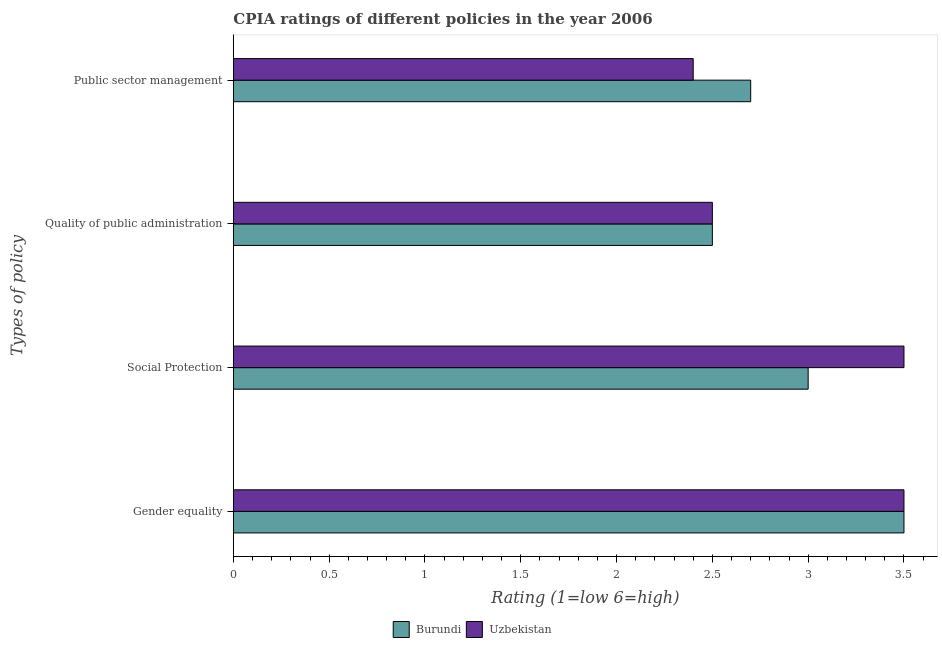How many different coloured bars are there?
Ensure brevity in your answer.  2. Are the number of bars per tick equal to the number of legend labels?
Provide a succinct answer. Yes. How many bars are there on the 2nd tick from the top?
Provide a short and direct response. 2. How many bars are there on the 3rd tick from the bottom?
Give a very brief answer. 2. What is the label of the 2nd group of bars from the top?
Offer a terse response. Quality of public administration. Across all countries, what is the maximum cpia rating of social protection?
Ensure brevity in your answer.  3.5. Across all countries, what is the minimum cpia rating of gender equality?
Provide a short and direct response. 3.5. In which country was the cpia rating of gender equality maximum?
Your answer should be compact. Burundi. In which country was the cpia rating of social protection minimum?
Ensure brevity in your answer.  Burundi. What is the total cpia rating of gender equality in the graph?
Your response must be concise. 7. What is the difference between the cpia rating of quality of public administration in Burundi and the cpia rating of gender equality in Uzbekistan?
Give a very brief answer. -1. What is the average cpia rating of public sector management per country?
Your answer should be very brief. 2.55. What is the difference between the cpia rating of public sector management and cpia rating of social protection in Uzbekistan?
Give a very brief answer. -1.1. Is the cpia rating of social protection in Uzbekistan less than that in Burundi?
Your answer should be very brief. No. What is the difference between the highest and the second highest cpia rating of gender equality?
Your answer should be compact. 0. What is the difference between the highest and the lowest cpia rating of quality of public administration?
Keep it short and to the point. 0. In how many countries, is the cpia rating of gender equality greater than the average cpia rating of gender equality taken over all countries?
Your answer should be compact. 0. Is the sum of the cpia rating of public sector management in Burundi and Uzbekistan greater than the maximum cpia rating of quality of public administration across all countries?
Keep it short and to the point. Yes. What does the 2nd bar from the top in Quality of public administration represents?
Your response must be concise. Burundi. What does the 2nd bar from the bottom in Social Protection represents?
Offer a terse response. Uzbekistan. Is it the case that in every country, the sum of the cpia rating of gender equality and cpia rating of social protection is greater than the cpia rating of quality of public administration?
Ensure brevity in your answer.  Yes. Are all the bars in the graph horizontal?
Keep it short and to the point. Yes. How many countries are there in the graph?
Offer a very short reply. 2. Does the graph contain grids?
Give a very brief answer. No. Where does the legend appear in the graph?
Keep it short and to the point. Bottom center. What is the title of the graph?
Keep it short and to the point. CPIA ratings of different policies in the year 2006. Does "American Samoa" appear as one of the legend labels in the graph?
Your answer should be very brief. No. What is the label or title of the X-axis?
Offer a terse response. Rating (1=low 6=high). What is the label or title of the Y-axis?
Offer a terse response. Types of policy. What is the Rating (1=low 6=high) of Burundi in Gender equality?
Your response must be concise. 3.5. What is the Rating (1=low 6=high) in Uzbekistan in Gender equality?
Provide a succinct answer. 3.5. What is the Rating (1=low 6=high) in Burundi in Social Protection?
Your answer should be compact. 3. What is the Rating (1=low 6=high) of Uzbekistan in Social Protection?
Your response must be concise. 3.5. What is the Rating (1=low 6=high) in Burundi in Quality of public administration?
Offer a very short reply. 2.5. What is the Rating (1=low 6=high) in Burundi in Public sector management?
Offer a terse response. 2.7. Across all Types of policy, what is the minimum Rating (1=low 6=high) of Uzbekistan?
Offer a terse response. 2.4. What is the total Rating (1=low 6=high) of Burundi in the graph?
Provide a short and direct response. 11.7. What is the total Rating (1=low 6=high) of Uzbekistan in the graph?
Your response must be concise. 11.9. What is the difference between the Rating (1=low 6=high) in Burundi in Gender equality and that in Quality of public administration?
Keep it short and to the point. 1. What is the difference between the Rating (1=low 6=high) of Uzbekistan in Gender equality and that in Quality of public administration?
Ensure brevity in your answer.  1. What is the difference between the Rating (1=low 6=high) of Burundi in Gender equality and that in Public sector management?
Your answer should be very brief. 0.8. What is the difference between the Rating (1=low 6=high) in Uzbekistan in Gender equality and that in Public sector management?
Provide a short and direct response. 1.1. What is the difference between the Rating (1=low 6=high) in Burundi in Social Protection and that in Quality of public administration?
Provide a succinct answer. 0.5. What is the difference between the Rating (1=low 6=high) of Burundi in Quality of public administration and that in Public sector management?
Ensure brevity in your answer.  -0.2. What is the difference between the Rating (1=low 6=high) in Uzbekistan in Quality of public administration and that in Public sector management?
Ensure brevity in your answer.  0.1. What is the difference between the Rating (1=low 6=high) in Burundi in Gender equality and the Rating (1=low 6=high) in Uzbekistan in Social Protection?
Your response must be concise. 0. What is the difference between the Rating (1=low 6=high) in Burundi in Gender equality and the Rating (1=low 6=high) in Uzbekistan in Public sector management?
Give a very brief answer. 1.1. What is the average Rating (1=low 6=high) in Burundi per Types of policy?
Provide a succinct answer. 2.92. What is the average Rating (1=low 6=high) of Uzbekistan per Types of policy?
Offer a terse response. 2.98. What is the ratio of the Rating (1=low 6=high) in Burundi in Gender equality to that in Social Protection?
Your response must be concise. 1.17. What is the ratio of the Rating (1=low 6=high) in Uzbekistan in Gender equality to that in Social Protection?
Provide a succinct answer. 1. What is the ratio of the Rating (1=low 6=high) of Uzbekistan in Gender equality to that in Quality of public administration?
Offer a terse response. 1.4. What is the ratio of the Rating (1=low 6=high) of Burundi in Gender equality to that in Public sector management?
Provide a succinct answer. 1.3. What is the ratio of the Rating (1=low 6=high) in Uzbekistan in Gender equality to that in Public sector management?
Keep it short and to the point. 1.46. What is the ratio of the Rating (1=low 6=high) of Uzbekistan in Social Protection to that in Quality of public administration?
Provide a succinct answer. 1.4. What is the ratio of the Rating (1=low 6=high) of Uzbekistan in Social Protection to that in Public sector management?
Offer a very short reply. 1.46. What is the ratio of the Rating (1=low 6=high) of Burundi in Quality of public administration to that in Public sector management?
Your answer should be very brief. 0.93. What is the ratio of the Rating (1=low 6=high) in Uzbekistan in Quality of public administration to that in Public sector management?
Your answer should be compact. 1.04. What is the difference between the highest and the second highest Rating (1=low 6=high) in Uzbekistan?
Ensure brevity in your answer.  0. What is the difference between the highest and the lowest Rating (1=low 6=high) in Uzbekistan?
Ensure brevity in your answer.  1.1. 